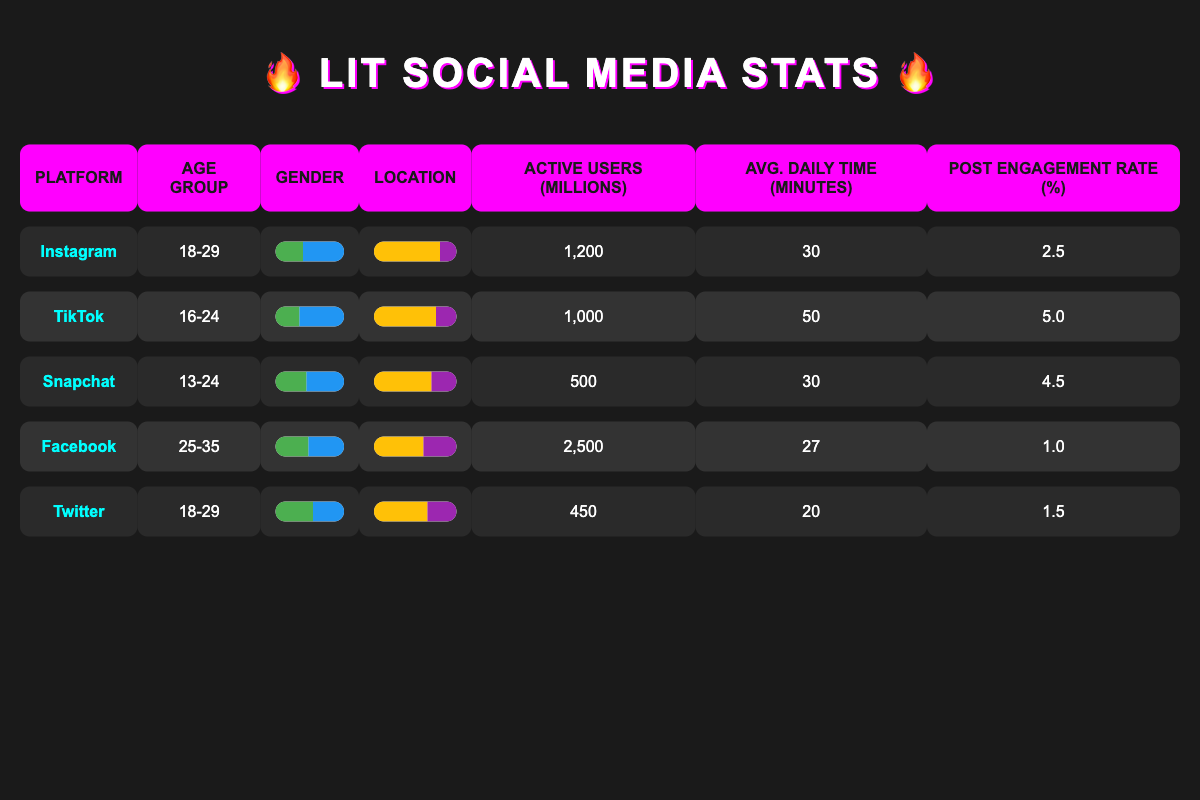What's the active user count for TikTok? The table shows that TikTok has 1,000 million active users listed under the "Active Users (Millions)" column.
Answer: 1000 Which platform has the highest post engagement rate? By comparing the "Post Engagement Rate (%)" column for all platforms, TikTok has a rate of 5.0, which is higher than other platforms.
Answer: TikTok What's the average daily time spent on Instagram? The "Avg. Daily Time (Minutes)" column shows that users spend an average of 30 minutes daily on Instagram.
Answer: 30 True or False: More users spend time on Facebook than on Instagram. The active user count for Facebook is 2,500 million while for Instagram it's 1,200 million. Therefore, the statement is true.
Answer: True What is the difference in active users between Facebook and Twitter? Facebook has 2,500 million active users, while Twitter has 450 million. To find the difference, subtract Twitter's users from Facebook's: 2,500 - 450 = 2,050 million.
Answer: 2050 Which gender has a higher representation on Snapchat? The gender representation for Snapchat shows 45% male and 55% female, indicating that females have a higher representation.
Answer: Female If we average the daily time spent on TikTok and Snapchat, what do we get? TikTok users spend 50 minutes daily, and Snapchat users spend 30 minutes. To find the average, add them (50 + 30 = 80) and divide by 2. 80 / 2 = 40 minutes.
Answer: 40 True or False: Twitter's user demographics are primarily urban. Looking at the "Location" section for Twitter, 65% of users are urban, confirming that the statement is true.
Answer: True What age group is the main demographic for Instagram and Twitter combined? Both Instagram and Twitter target the 18-29 age group. Since both platforms are aimed at the same age demographic, we can say it’s 18-29 years old.
Answer: 18-29 Calculate the total active users across all platforms listed. The total active users are: 1200 + 1000 + 500 + 2500 + 450 = 4650 million.
Answer: 4650 